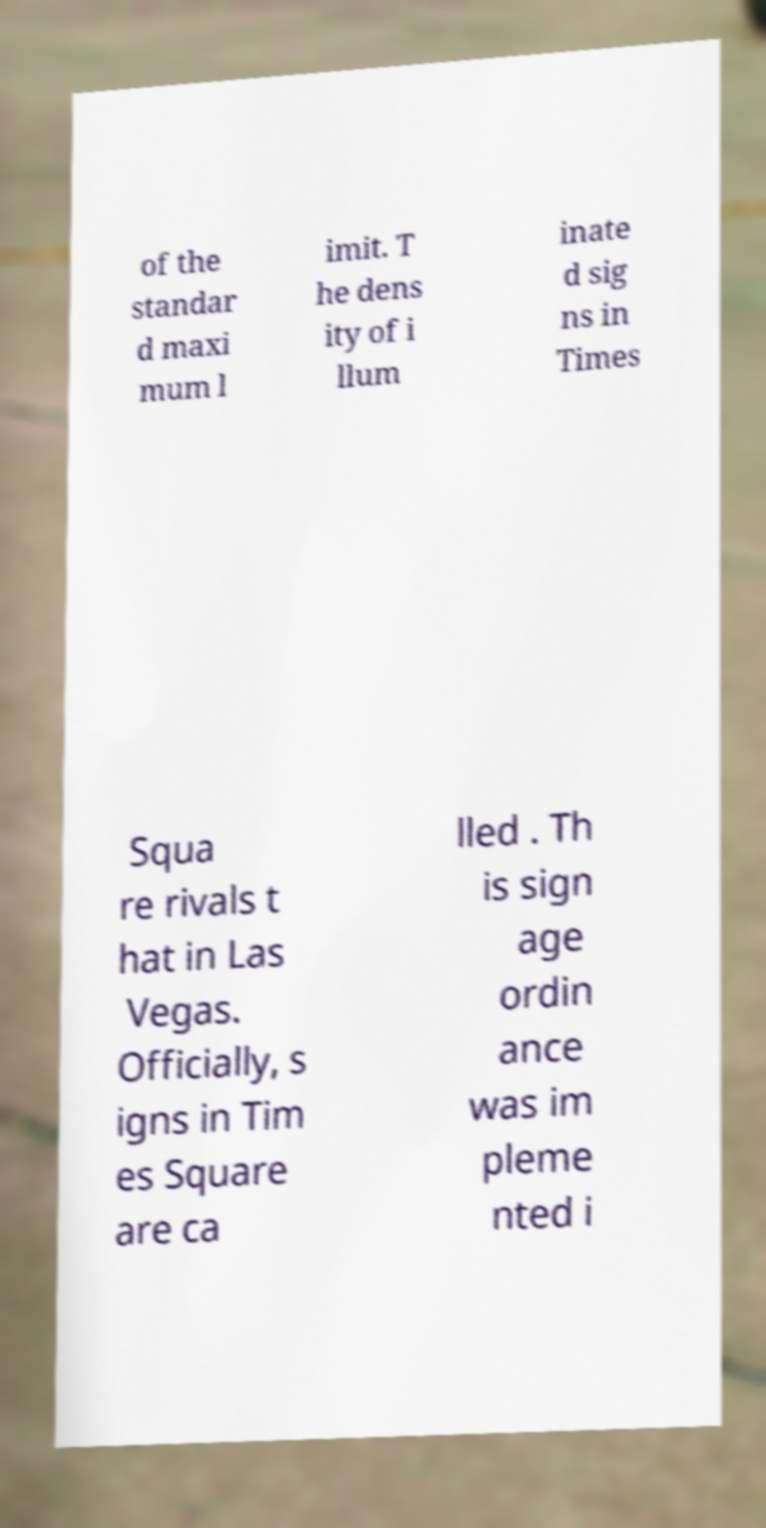Please identify and transcribe the text found in this image. of the standar d maxi mum l imit. T he dens ity of i llum inate d sig ns in Times Squa re rivals t hat in Las Vegas. Officially, s igns in Tim es Square are ca lled . Th is sign age ordin ance was im pleme nted i 